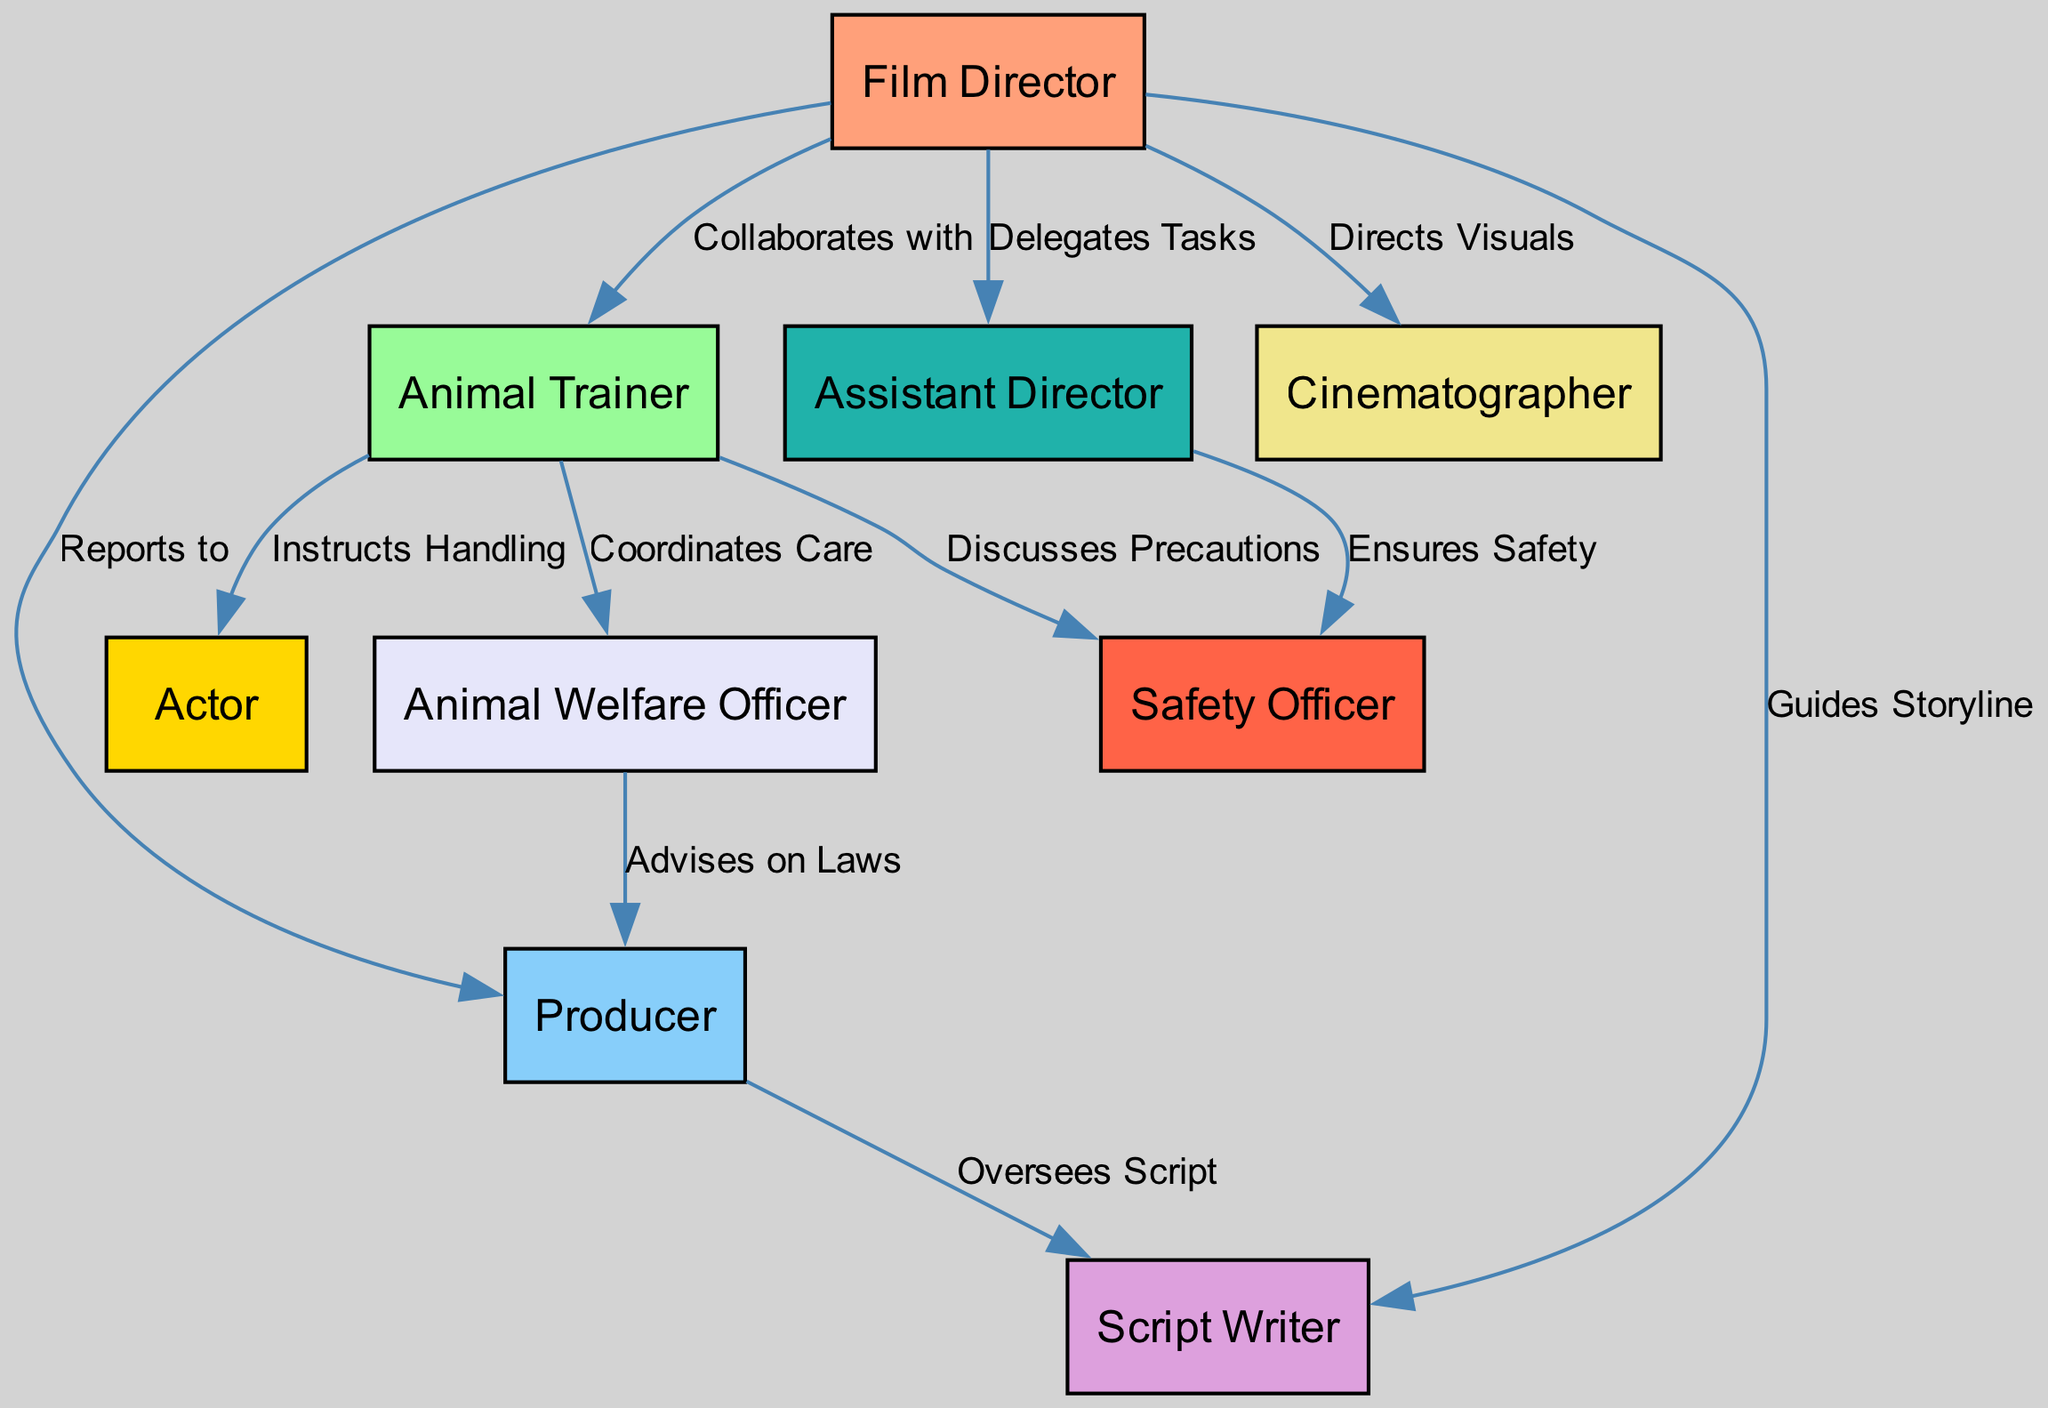What is the total number of crew members depicted in the diagram? The diagram represents a total of 9 crew members, including the film director, animal trainer, producer, script writer, cinematographer, animal welfare officer, actor, assistant director, and safety officer. This is counted by simply identifying the nodes present in the diagram.
Answer: 9 Who does the film director collaborate with? The film director collaborates with the animal trainer, as indicated by the edge labeled "Collaborates with" that connects these two nodes in the diagram.
Answer: Animal Trainer How many distinct tasks are delegated by the film director? The film director delegates tasks to the assistant director. Furthermore, he also guides the storyline, directs visuals, and collaborates with the animal trainer. Therefore, the distinct task delegation includes 4 roles but focuses mainly on the assistant director for task delegation.
Answer: 1 What role advises the producer on laws? The animal welfare officer advises the producer on laws, which is shown by the edge labeled "Advises on Laws" connecting the animal welfare officer to the producer in the diagram.
Answer: Animal Welfare Officer Which two roles coordinate with each other for animal care? The animal trainer coordinates with the animal welfare officer for the care of animals, as represented by the edge connecting these two nodes labeled "Coordinates Care."
Answer: Animal Trainer and Animal Welfare Officer How does the assistant director ensure safety? The assistant director ensures safety through the safety officer, as shown by the edge labeled "Ensures Safety" connecting these two nodes. This indicates a direct responsibility of the assistant director in overseeing safety measures by collaborating with the safety officer.
Answer: Safety Officer What is the role of the script writer concerning the producer? The script writer is overseen by the producer, as indicated by the edge labeled "Oversees Script" connecting the producer to the script writer. This means that the producer has an overarching role regarding the development and progress of the script.
Answer: Oversees Script Which crew member instructs handling techniques to the actor? The animal trainer instructs handling techniques to the actor, as indicated by the edge labeled "Instructs Handling," showing the direct instructional role of the animal trainer in relation to the actor.
Answer: Animal Trainer How many connections does the animal trainer have in total? The animal trainer has a total of 3 connections: it collaborates with the film director, instructs the actor, and coordinates care with the animal welfare officer. By counting all the edges connected to the animal trainer node, we determine that it has 3 distinct relationships.
Answer: 3 